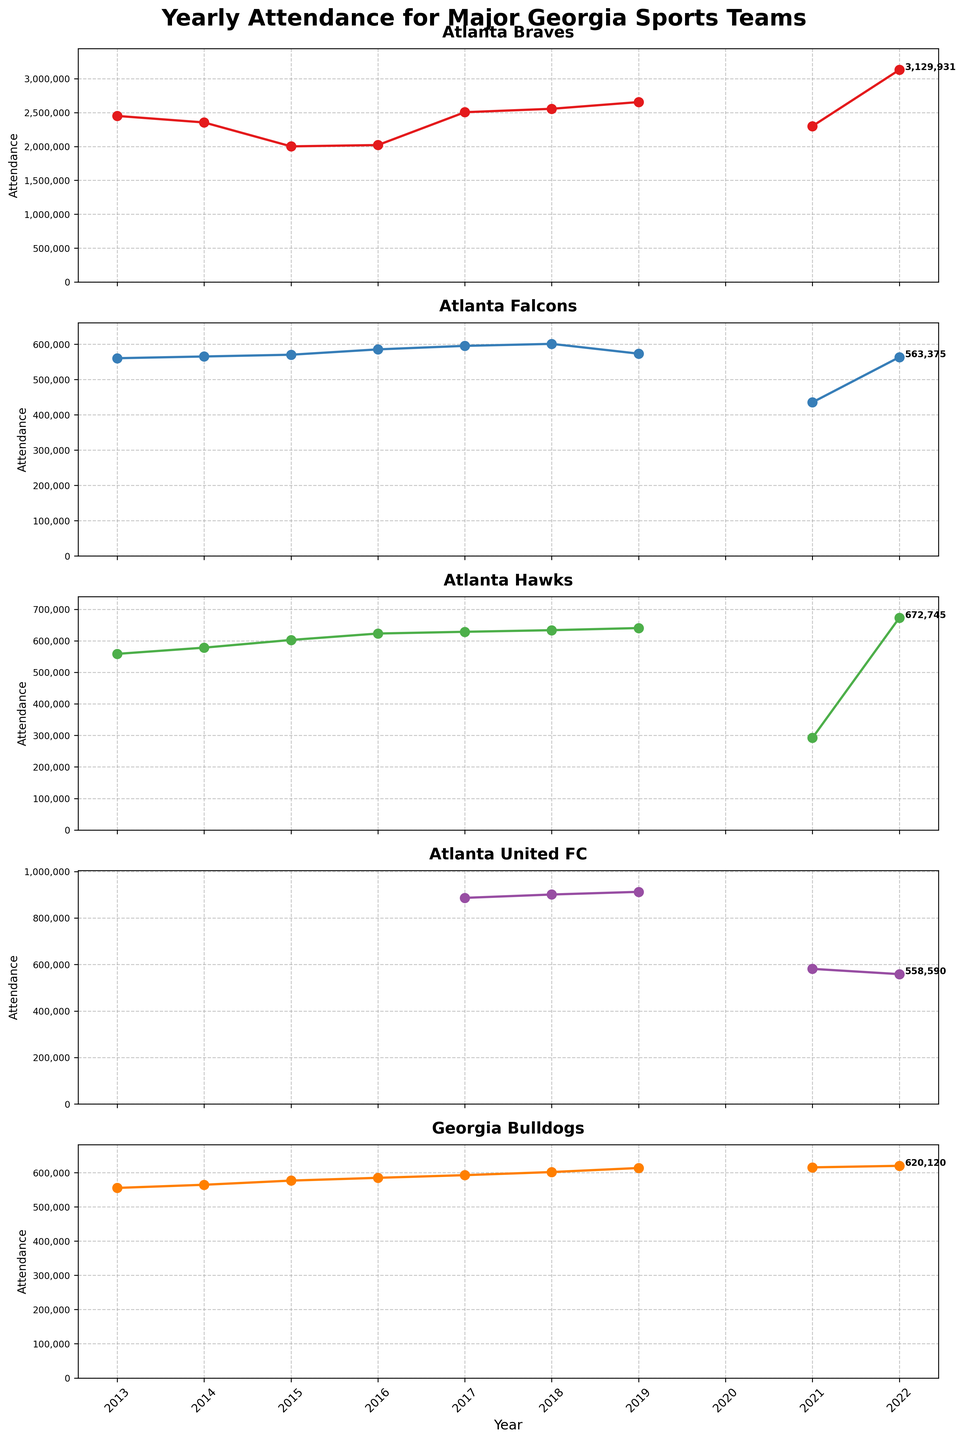How many teams' attendance tend over the years is shown in the figure? The figure has a subplot for each team. Counting the number of subplots reveals that the attendance trends of five teams are shown: Atlanta Braves, Atlanta Falcons, Atlanta Hawks, Atlanta United FC, and Georgia Bulldogs.
Answer: 5 Which team had the highest yearly attendance in 2022? By identifying the data point of 2022 in each subplot, the highest attendance can be observed under the Atlanta Braves, indicating their attendance was the highest in 2022.
Answer: Atlanta Braves How did Atlanta United FC's attendance change from 2017 to 2019? Looking at the Atlanta United FC subplot, the attendance increased from approximately 886,625 in 2017 to 912,495 in 2019.
Answer: Increased Which year had no attendance data for any team, and why? By examining the x-axis labels and the marked data points, the year 2020 has no data for any team, likely due to the global COVID-19 pandemic that impacted sporting events.
Answer: 2020 Compare the attendance figures for Atlanta Falcons and Atlanta Hawks in 2021. Which team had higher attendance? By observing the respective subplots for 2021, the data points show that Atlanta Falcons had an attendance of 435,456, while Atlanta Hawks had a lower attendance of 292,075.
Answer: Atlanta Falcons Did the Georgia Bulldogs' attendance increase or decrease from 2013 to 2022? Checking the starting and ending points of the Georgia Bulldogs' subplot from 2013 to 2022 shows an overall increase from 555,550 to 620,120.
Answer: Increase What was the trend in attendance for the Atlanta Braves from 2015 to 2022? Observing the data points for the Atlanta Braves subplot from 2015 (2001392) to 2022 (3129931) shows a general increasing trend with occasional fluctuations.
Answer: Increasing Which teams have experienced a steady increase in attendance from 2013 to 2019? By analyzing the trends in each subplot from 2013 to 2019, Atlanta Hawks and Atlanta Braves display a consistent increase in their attendance figures.
Answer: Atlanta Hawks, Atlanta Braves In which years did the Atlanta Falcons have an attendance of over 560,000? By checking the year labels and corresponding data points in the Atlanta Falcons subplot, the years with attendance over 560,000 are 2013, 2014, 2015, 2016, 2017, and 2018.
Answer: 2013, 2014, 2015, 2016, 2017, 2018 How does the attendance of Georgia Bulldogs in 2022 compare to their attendance in 2019? Comparing the data points in the Georgia Bulldogs subplot for 2022 (620,120) and 2019 (613,790) shows a slight increase in attendance.
Answer: Increased 